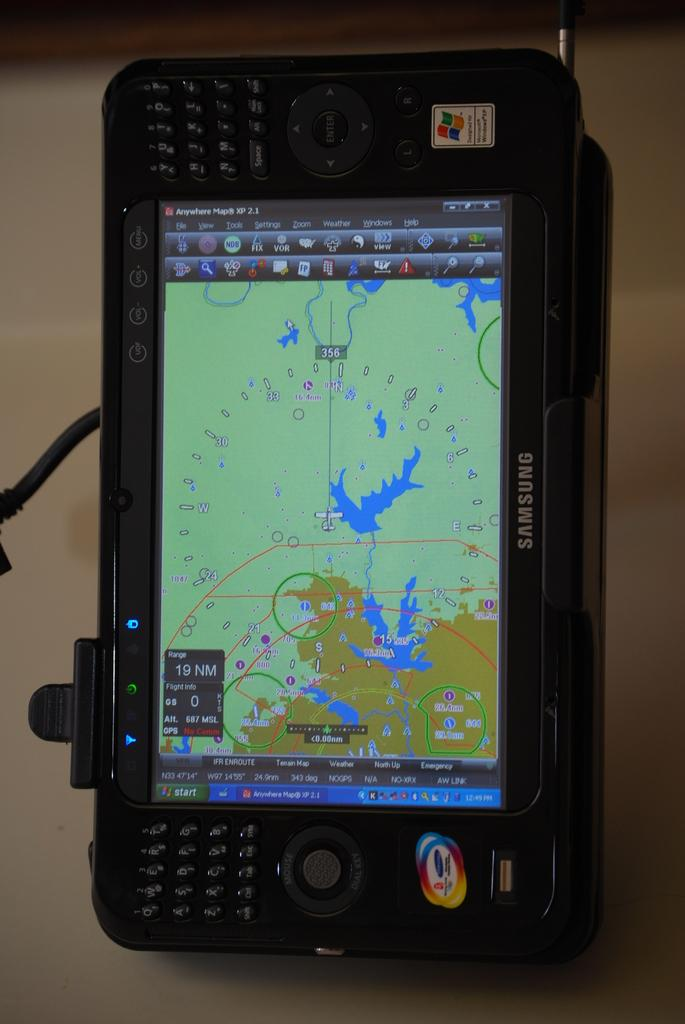<image>
Offer a succinct explanation of the picture presented. A GPS device with a map on it says Samsung on its side. 